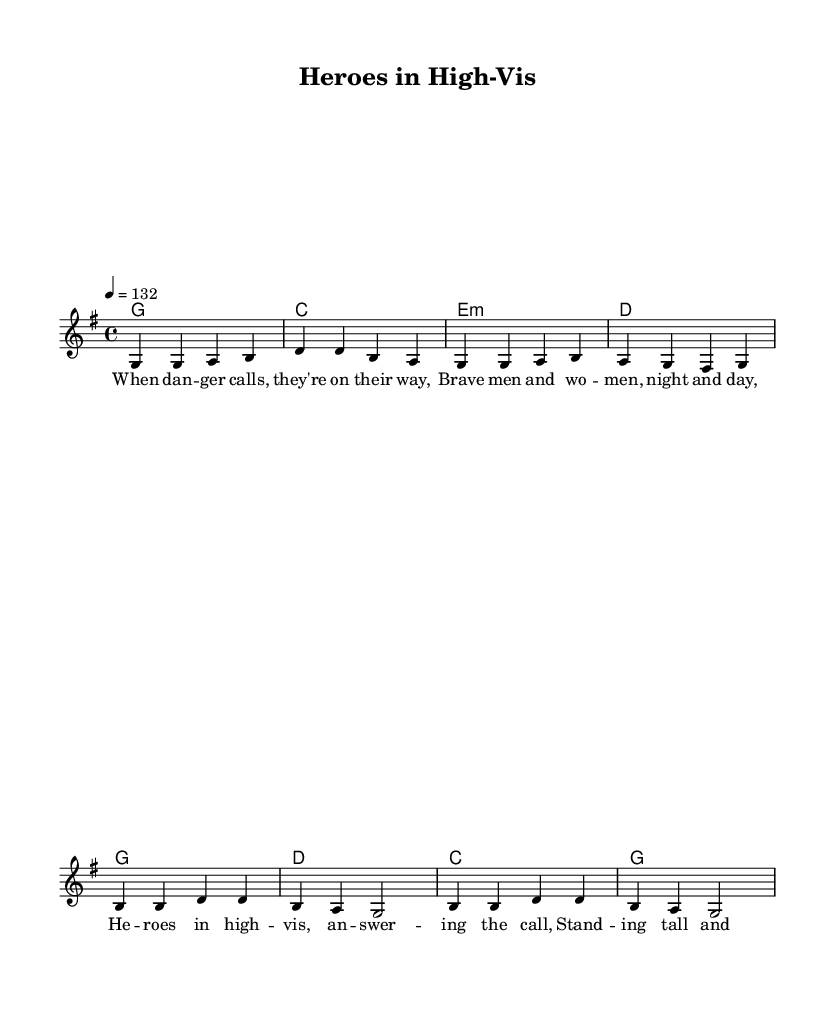What key is this music in? The key signature indicates it is G major, which has one sharp. This is represented at the beginning of the sheet music.
Answer: G major What is the time signature of this song? The time signature is 4/4, which means there are four beats in a measure. This is found near the beginning of the sheet music.
Answer: 4/4 What is the tempo marking for this piece? The tempo marking is 4 = 132, which indicates that there are 132 beats per minute. This also appears at the top of the sheet music.
Answer: 132 How many measures are in the verse section? By counting the measures in the melody section labeled as "Verse," there are four measures present before transitioning to the chorus.
Answer: 4 What type of harmonies are used in the verse? The harmonies in the verse section consist of four chords: G, C, E minor, and D. These chords are listed under the harmonies section aligned with the melody.
Answer: G, C, E minor, D What genre of music does this piece represent? The title and lyrical content indicate it represents Country Rock, particularly with themes about first responders and emergency workers. This is evident in both the title and the lyrical themes discussed.
Answer: Country Rock How do the chorus lyrics begin? The chorus lyrics start with "Heroes in high-vis," which is visible in the lyrics section of the sheet music.
Answer: Heroes in high-vis 